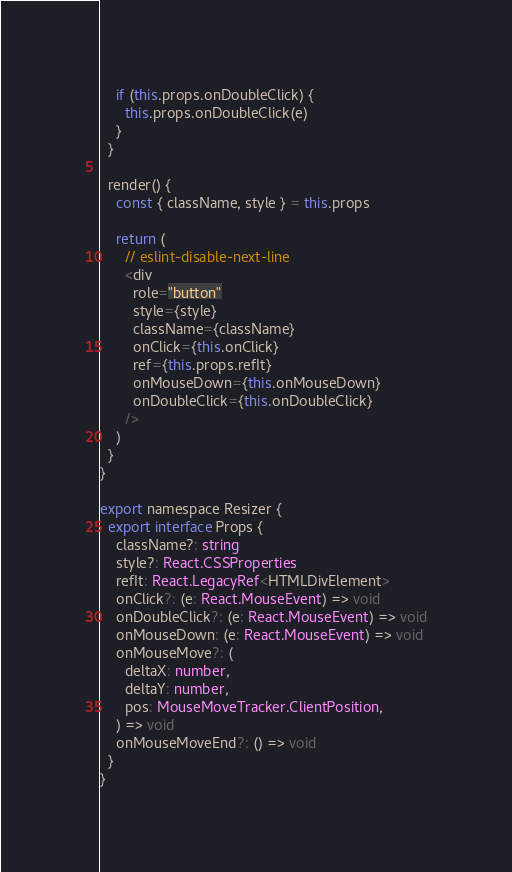Convert code to text. <code><loc_0><loc_0><loc_500><loc_500><_TypeScript_>    if (this.props.onDoubleClick) {
      this.props.onDoubleClick(e)
    }
  }

  render() {
    const { className, style } = this.props

    return (
      // eslint-disable-next-line
      <div
        role="button"
        style={style}
        className={className}
        onClick={this.onClick}
        ref={this.props.refIt}
        onMouseDown={this.onMouseDown}
        onDoubleClick={this.onDoubleClick}
      />
    )
  }
}

export namespace Resizer {
  export interface Props {
    className?: string
    style?: React.CSSProperties
    refIt: React.LegacyRef<HTMLDivElement>
    onClick?: (e: React.MouseEvent) => void
    onDoubleClick?: (e: React.MouseEvent) => void
    onMouseDown: (e: React.MouseEvent) => void
    onMouseMove?: (
      deltaX: number,
      deltaY: number,
      pos: MouseMoveTracker.ClientPosition,
    ) => void
    onMouseMoveEnd?: () => void
  }
}
</code> 